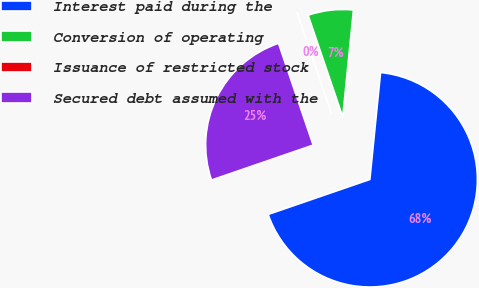Convert chart to OTSL. <chart><loc_0><loc_0><loc_500><loc_500><pie_chart><fcel>Interest paid during the<fcel>Conversion of operating<fcel>Issuance of restricted stock<fcel>Secured debt assumed with the<nl><fcel>68.14%<fcel>6.81%<fcel>0.0%<fcel>25.05%<nl></chart> 